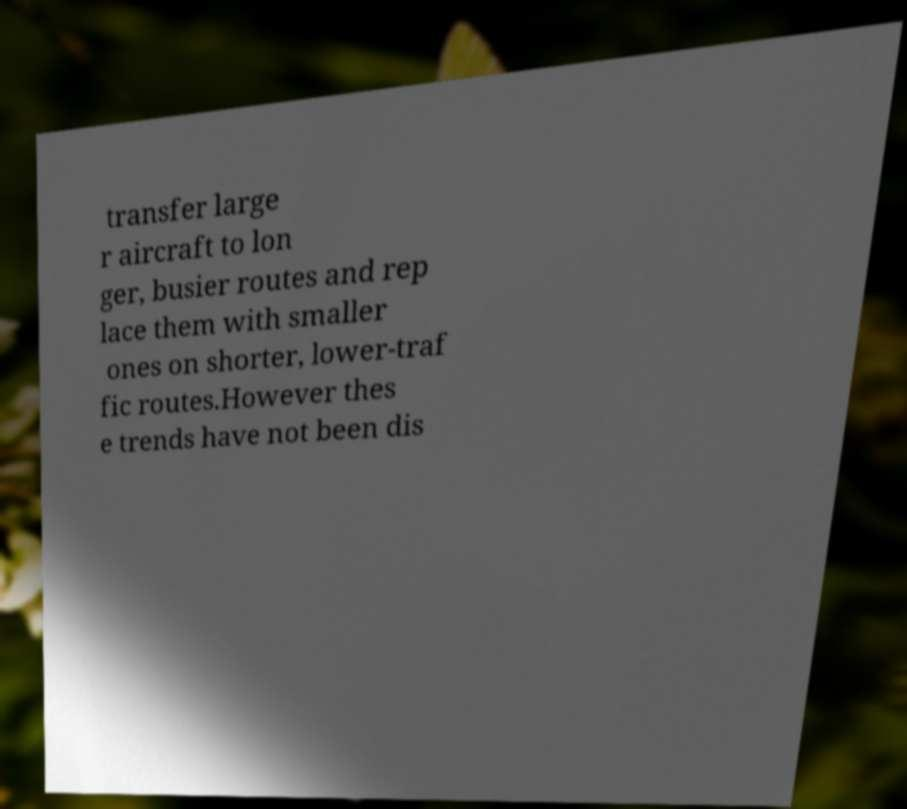Please read and relay the text visible in this image. What does it say? transfer large r aircraft to lon ger, busier routes and rep lace them with smaller ones on shorter, lower-traf fic routes.However thes e trends have not been dis 